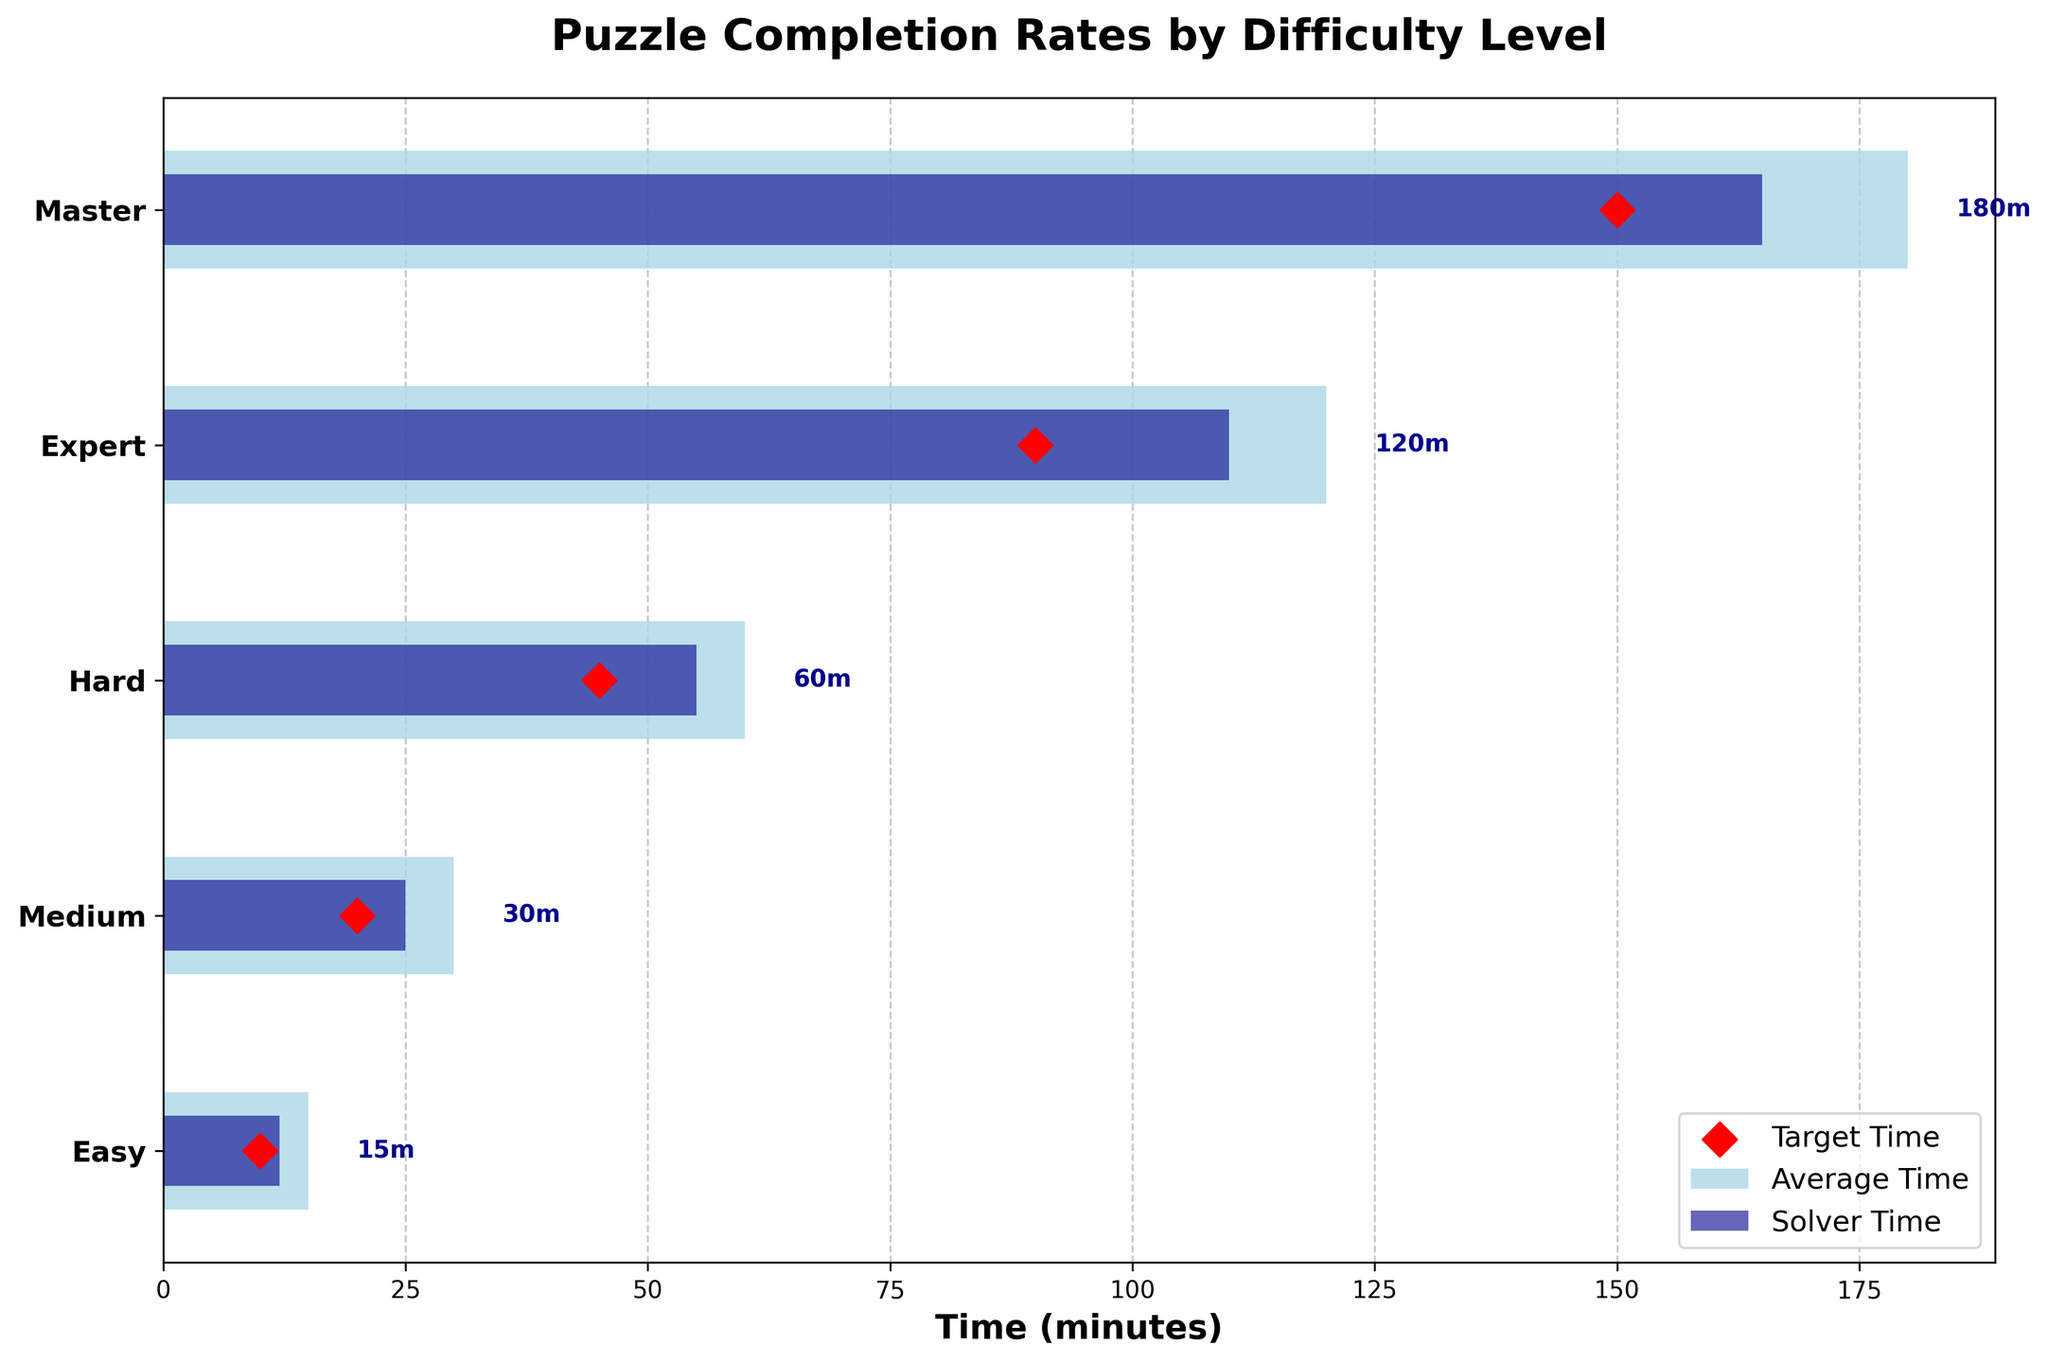What is the title of the figure? The title is usually located at the top of the figure, depicting the main subject or purpose of the plot.
Answer: Puzzle Completion Rates by Difficulty Level Which difficulty level has the highest solver time? By observing the lengths of the dark blue bars, you can see which one extends the furthest, indicating the highest solver time.
Answer: Master What is the target time for Medium difficulty puzzles? Look for the red diamond markers that represent the target times and find the one corresponding to the Medium difficulty level.
Answer: 20 minutes How much faster are the actual solver times for Easy puzzles compared to the target time? Subtract the target time for Easy puzzles (10 minutes) from the actual solver time (12 minutes) to get the difference.
Answer: 2 minutes slower What is the difference between the average time and the solver time for Hard puzzles? Subtract the solver time for Hard puzzles (55 minutes) from the average time (60 minutes) to find the difference.
Answer: 5 minutes Which difficulty level has the smallest difference between the solver time and the target time? Calculate the differences for each difficulty level and find the smallest one. For Easy: 2 minutes, Medium: 5 minutes, Hard: 10 minutes, Expert: 20 minutes, Master: 15 minutes.
Answer: Easy On average, how much faster are puzzles completed compared to their average times? For each difficulty level, subtract the solver time from the average time to find the differences, then compute the average of these differences. Easy: 15 - 12 = 3, Medium: 30 - 25 = 5, Hard: 60 - 55 = 5, Expert: 120 - 110 = 10, Master: 180 - 165 = 15. Calculate the average: (3 + 5 + 5 + 10 + 15) / 5 = 7.6
Answer: 7.6 minutes Which difficulty level shows the largest gap between average time and target time? Calculate the differences between average and target times for each difficulty level and identify the largest one. Easy: 15 - 10 = 5, Medium: 30 - 20 = 10, Hard: 60 - 45 = 15, Expert: 120 - 90 = 30, Master: 180 - 150 = 30.
Answer: Expert and Master (tie) How much more time does a Master level puzzle take on average compared to an Easy level puzzle? Subtract the average time for an Easy puzzle (15 minutes) from the average time for a Master puzzle (180 minutes).
Answer: 165 minutes 